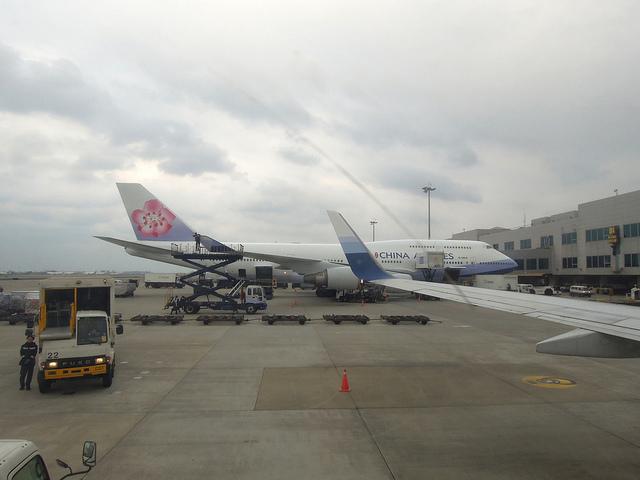Can you see an ocean?
Be succinct. No. Where is the plane?
Keep it brief. Airport. Is this night time?
Quick response, please. No. Is this a passenger airplane?
Answer briefly. Yes. What is that tail off?
Quick response, please. Flower. Was this taken at an airport?
Be succinct. Yes. How many planes are there?
Concise answer only. 2. What aircraft is this?
Concise answer only. Passenger plane. What is on the runway?a?
Concise answer only. Plane. What is the picture on the plane?
Keep it brief. Flower. What is the building?
Answer briefly. Airport. Sunny or overcast?
Quick response, please. Overcast. Are the planes connected to a jet bridge?
Answer briefly. No. What is written on the tail of the plane?
Give a very brief answer. Flower. Are the people walking to the plane?
Concise answer only. No. Why color is the sky?
Concise answer only. Gray. Is the sky clear?
Keep it brief. No. What airline do these planes belong to?
Short answer required. China airlines. Are the people getting on the plane?
Keep it brief. No. How many planes do you see?
Keep it brief. 2. What color is the truck?
Answer briefly. White. Why is the vehicle on the runway?
Answer briefly. Parked. Was this plane built during World War II?
Answer briefly. No. Is this picture taken on a roadway?
Be succinct. No. How many red cones are in the picture?
Give a very brief answer. 1. Does the building have two stories?
Concise answer only. Yes. Are there clouds in the sky?
Answer briefly. Yes. 